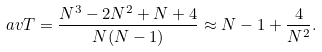<formula> <loc_0><loc_0><loc_500><loc_500>\ a v { T } = \frac { N ^ { 3 } - 2 N ^ { 2 } + N + 4 } { N ( N - 1 ) } \approx N - 1 + \frac { 4 } { N ^ { 2 } } .</formula> 